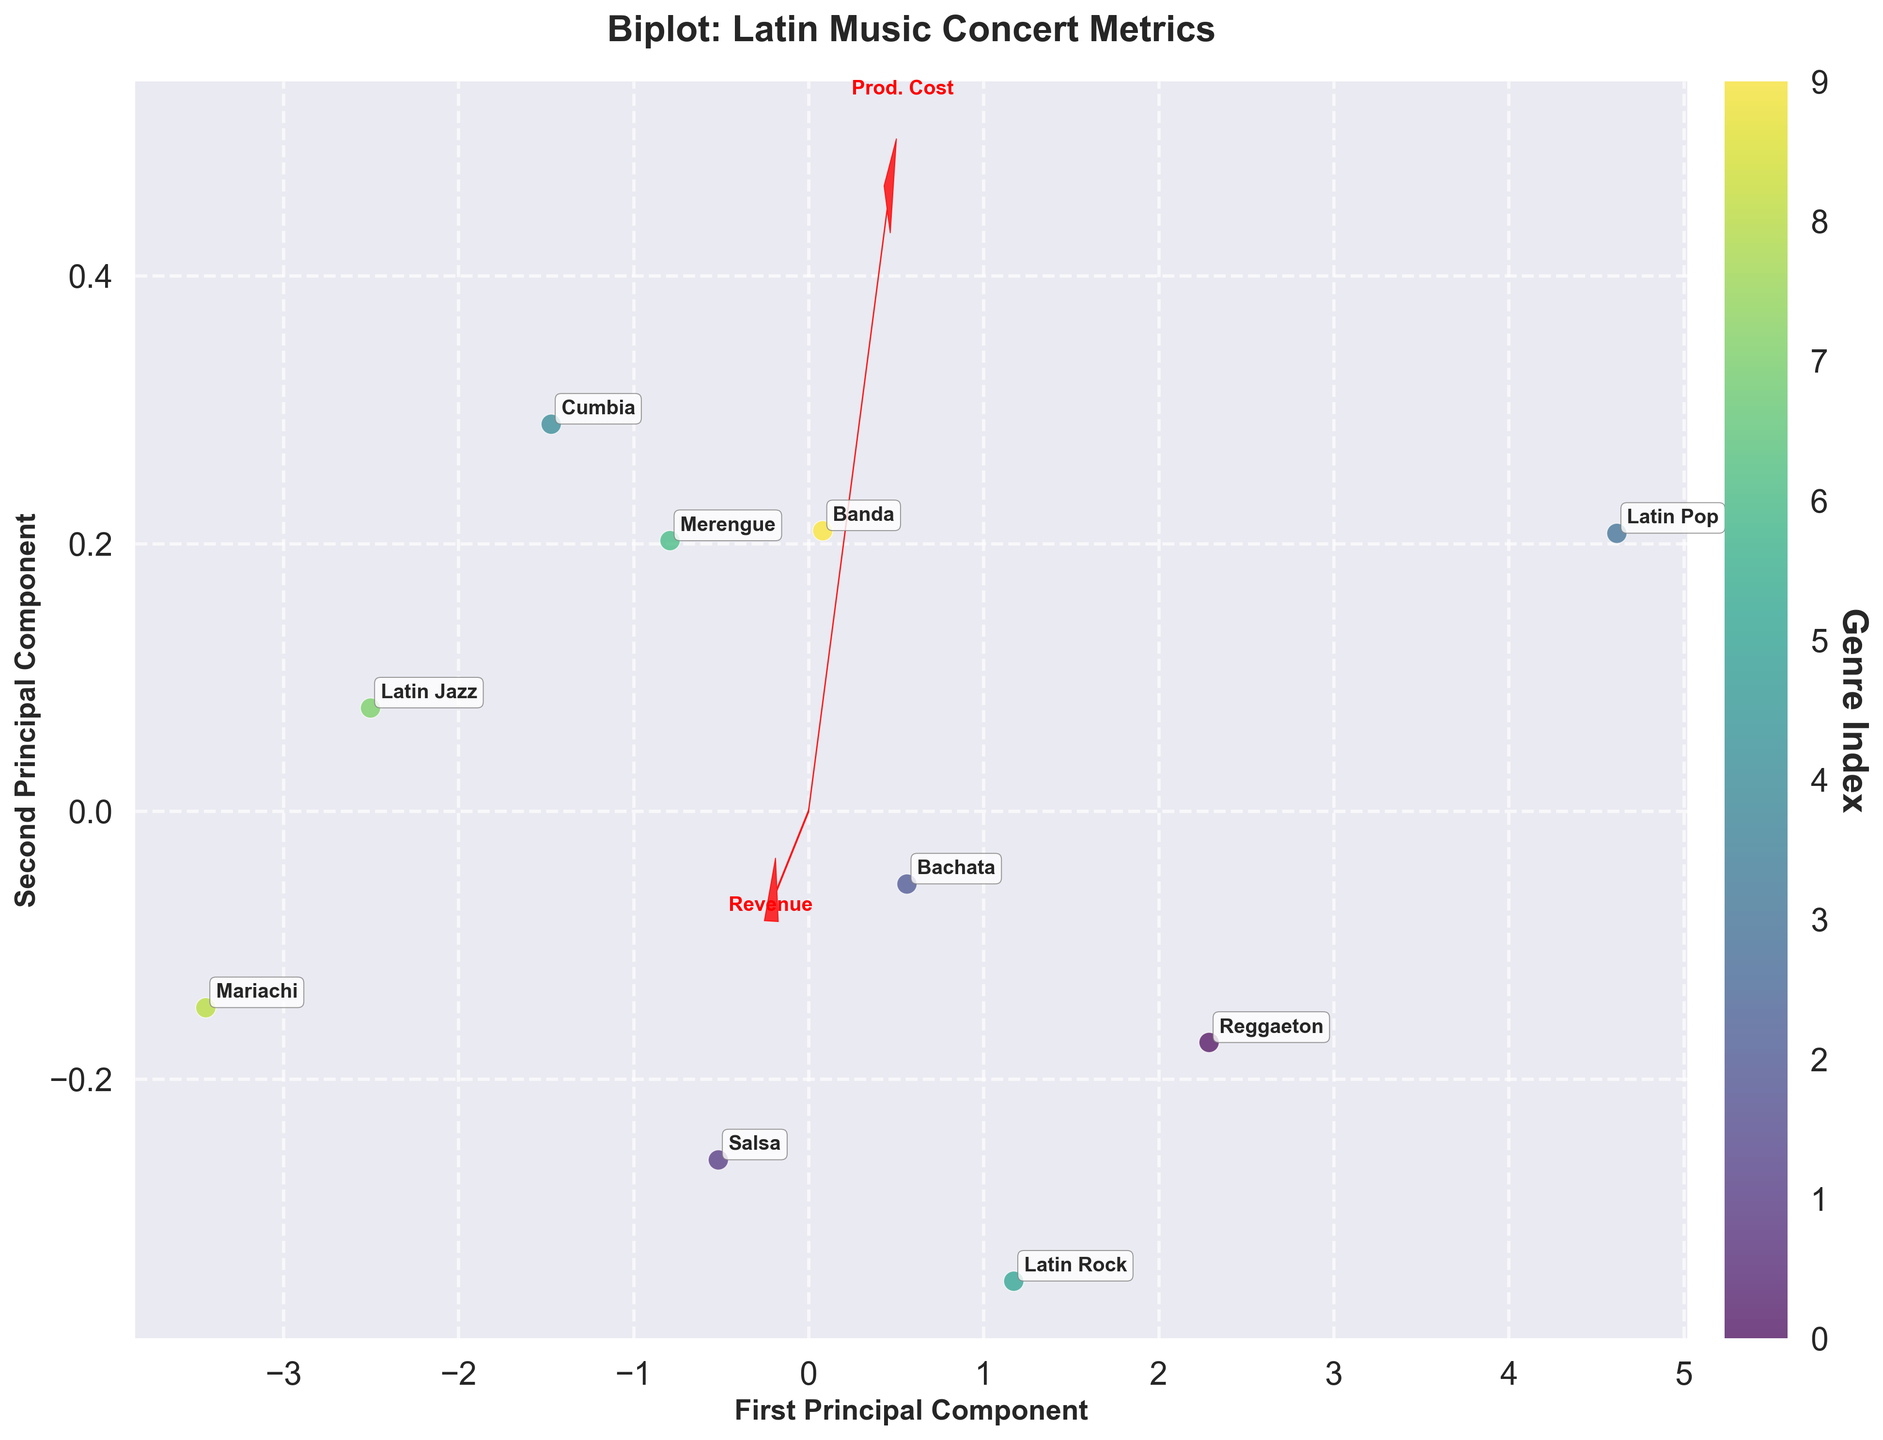Which genre has the highest first principal component score? By observing the placement of the genres along the first principal component (x-axis), we identify that the genre farthest to the right has the highest score.
Answer: Latin Pop Which genre is closest to the origin? To determine which genre is closest to the origin, look for the genre label situated nearest to (0,0) in the plot.
Answer: Mariachi Which feature vector is pointing most directly to the top-right of the plot? Examine the arrows representing the feature vectors; the one that points most upward and to the right indicates the most significant contributing feature in that direction.
Answer: Revenue Which two genres are nearest to each other based on their principal component scores? Determine the physical distance between each pair of genre labels on the biplot. The two genres that are closest to each other represent the answer.
Answer: Salsa and Merengue What is the overall direction of the 'Artist Fee' feature vector? Observe the 'Artist Fee' vector's direction by checking the label and the direction of the corresponding arrow.
Answer: Bottom-right Which genre corresponds to the lowest revenue and production cost? Look at the placement of each genre in the figure and identify the one located towards both the lower end of the x-axis and y-axis, aligning with lower values for both dimensions.
Answer: Mariachi Compare the distances from the origin to the Latin Pop and Reggaeton genres. Which one is farther? Measure the distance of both Latin Pop and Reggaeton from (0,0) using their coordinates in the plot. The one with a larger distance value is farther.
Answer: Latin Pop If a new genre is located at the second principal component's negative extreme, which feature would likely have a minimal value for this genre? The negative extreme of the second principal component (y-axis) indicates low values for the features indicated by vectors pointing upward-along this axis.
Answer: Avg Ticket Price Which genre is likely to have the highest venue capacity based on the biplot? Assess which genre aligns closely with the 'Venue Capacity' feature vector pointing direction.
Answer: Latin Pop Which genres are found aligned with the direction of the 'Production Cost' vector? Identify the categories located in the general direction of the 'Production Cost' arrow, which tells that the vectors are correlated with this feature.
Answer: Latin Pop, Reggaeton 